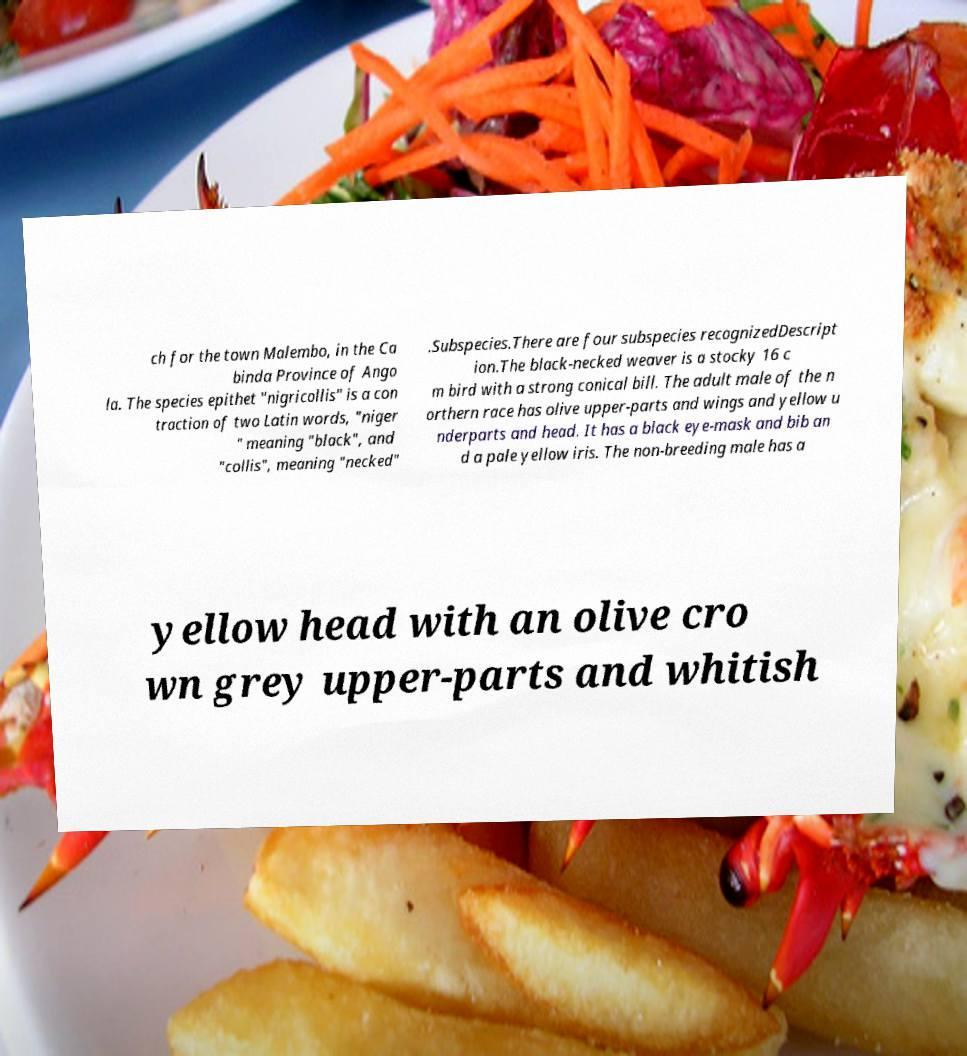Could you extract and type out the text from this image? ch for the town Malembo, in the Ca binda Province of Ango la. The species epithet "nigricollis" is a con traction of two Latin words, "niger " meaning "black", and "collis", meaning "necked" .Subspecies.There are four subspecies recognizedDescript ion.The black-necked weaver is a stocky 16 c m bird with a strong conical bill. The adult male of the n orthern race has olive upper-parts and wings and yellow u nderparts and head. It has a black eye-mask and bib an d a pale yellow iris. The non-breeding male has a yellow head with an olive cro wn grey upper-parts and whitish 